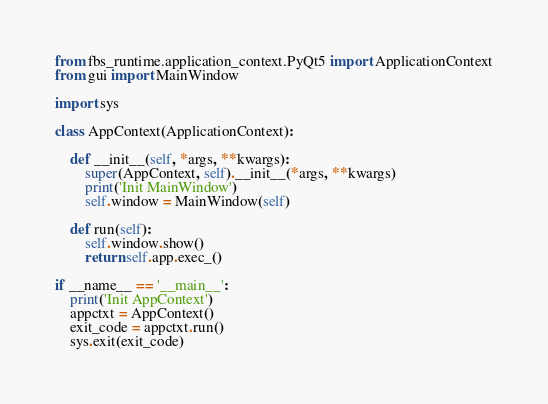Convert code to text. <code><loc_0><loc_0><loc_500><loc_500><_Python_>from fbs_runtime.application_context.PyQt5 import ApplicationContext
from gui import MainWindow

import sys

class AppContext(ApplicationContext):

    def __init__(self, *args, **kwargs):
        super(AppContext, self).__init__(*args, **kwargs)
        print('Init MainWindow')
        self.window = MainWindow(self)

    def run(self):
        self.window.show()
        return self.app.exec_()

if __name__ == '__main__':
    print('Init AppContext')
    appctxt = AppContext()
    exit_code = appctxt.run()
    sys.exit(exit_code)</code> 